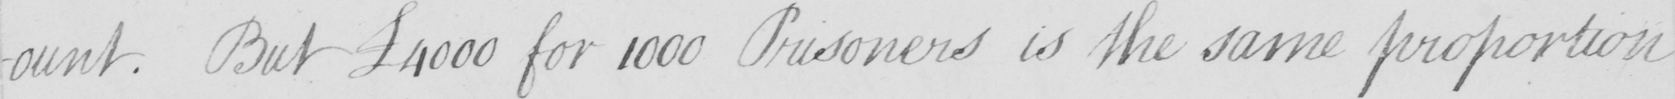Can you read and transcribe this handwriting? -ount . But  £4000 for 1000 Prisoners is the same proportion 